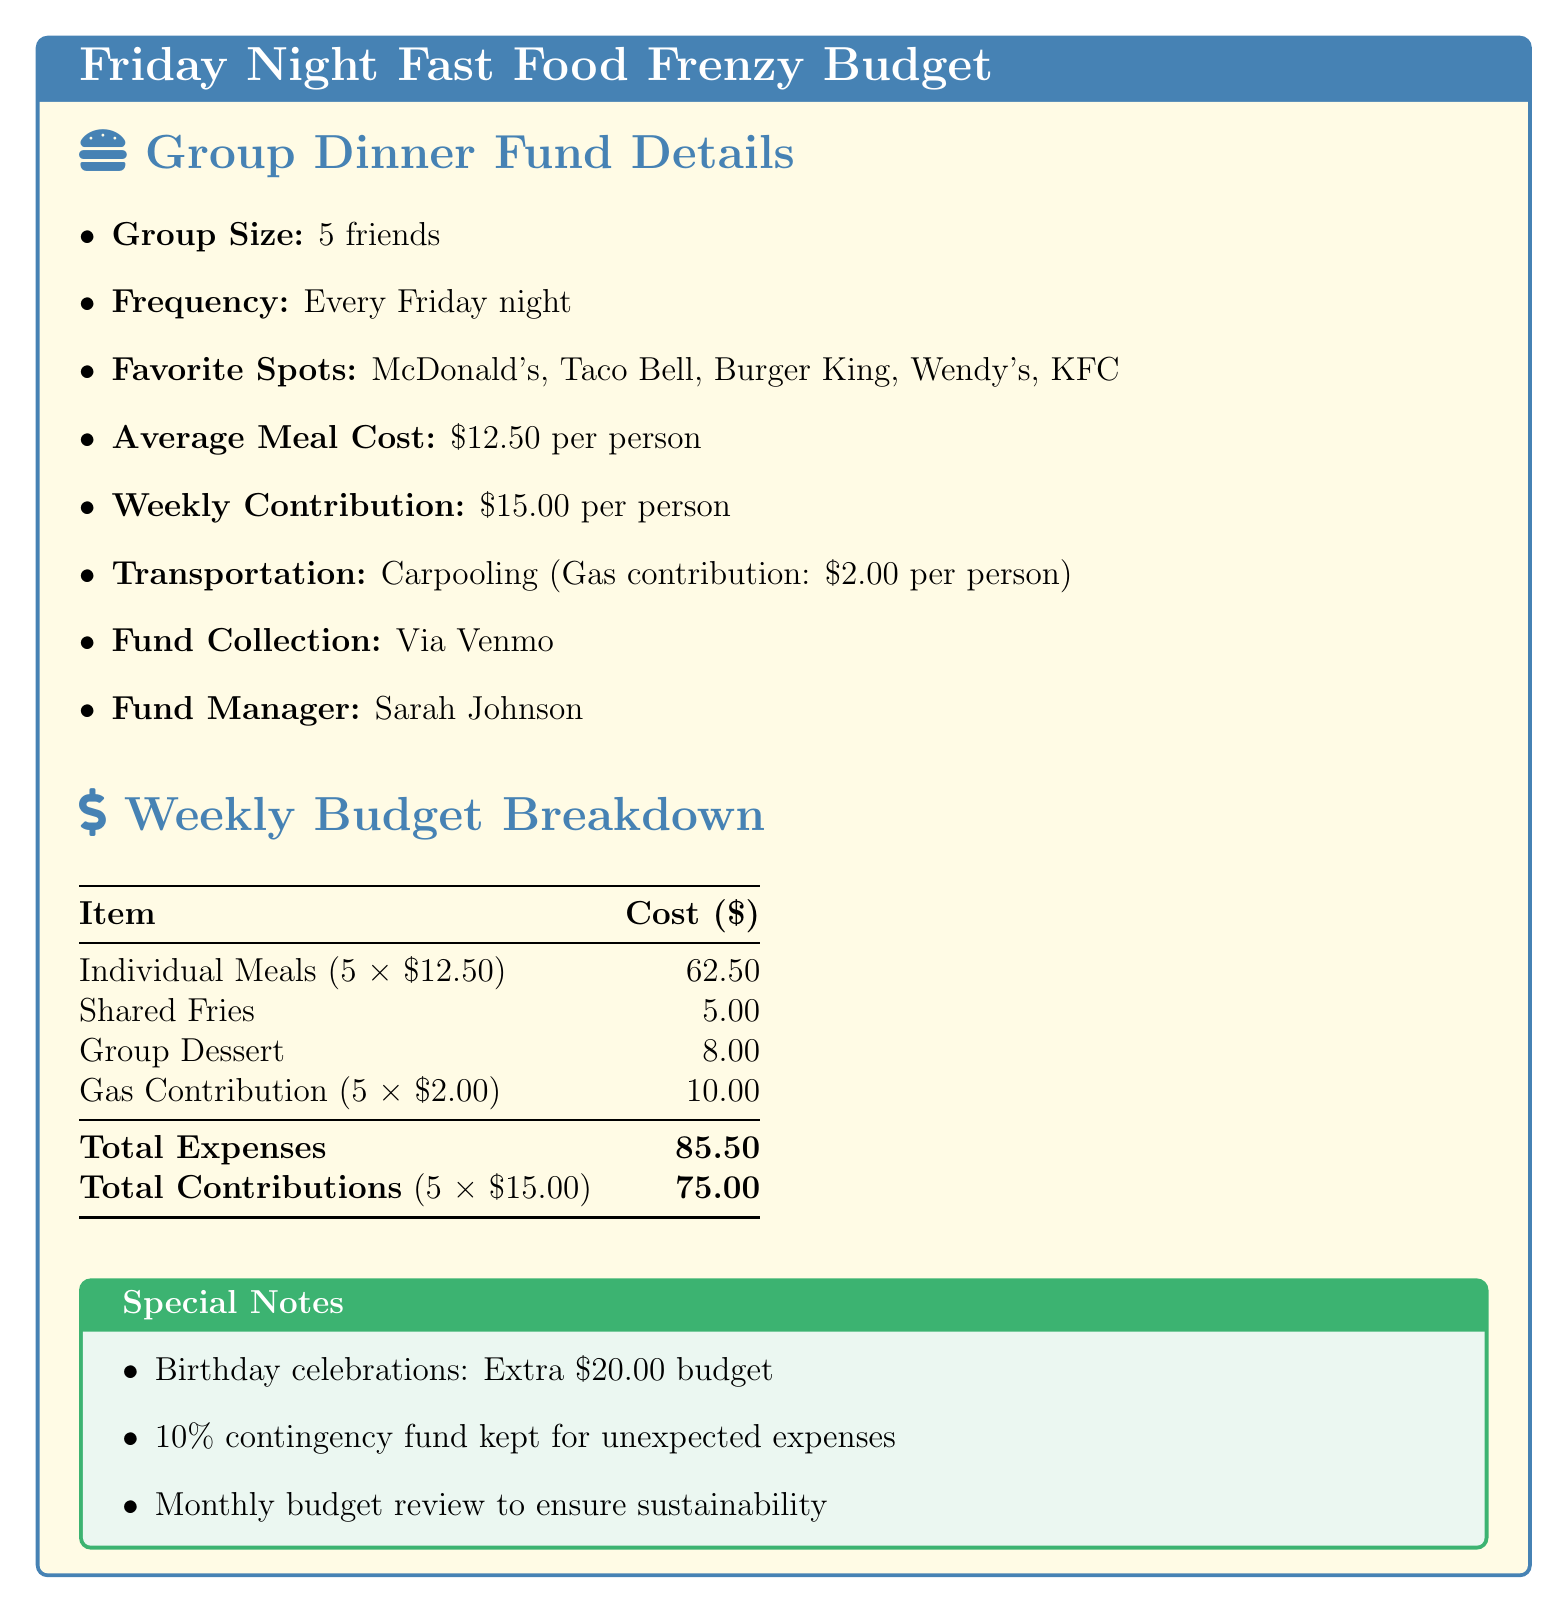What is the group size? The document states that the group consists of 5 friends.
Answer: 5 friends What is the average meal cost per person? According to the document, the average meal cost is $12.50 per person.
Answer: $12.50 How much does each person contribute weekly? The document mentions that each person's weekly contribution is $15.00.
Answer: $15.00 What is the total expense listed? The total expenses for the group dinner amount to $85.50 as indicated in the budget breakdown.
Answer: $85.50 How much is allocated for shared fries? The document specifies that the cost allocated for shared fries is $5.00.
Answer: $5.00 Who is the fund manager? The fund manager is named Sarah Johnson, as stated in the document.
Answer: Sarah Johnson What is the gas contribution per person? The document indicates that the gas contribution per person is $2.00.
Answer: $2.00 What percentage is kept for unexpected expenses? The document mentions a 10% contingency fund for unexpected expenses.
Answer: 10% How often is the budget reviewed? The document states that there is a monthly budget review to ensure sustainability.
Answer: Monthly 